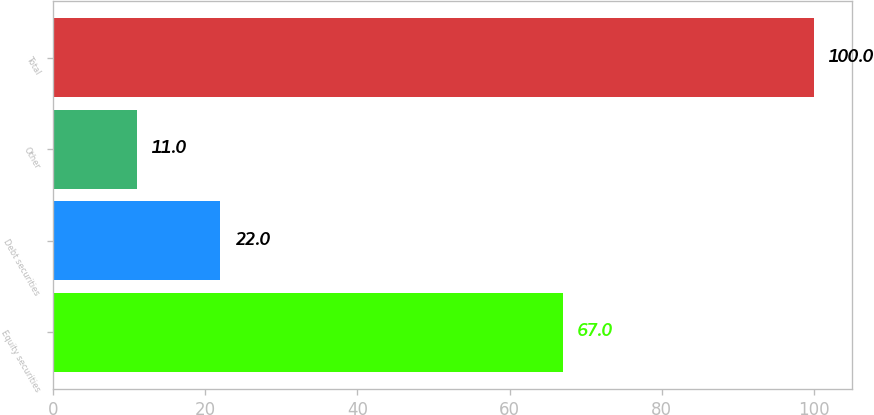Convert chart to OTSL. <chart><loc_0><loc_0><loc_500><loc_500><bar_chart><fcel>Equity securities<fcel>Debt securities<fcel>Other<fcel>Total<nl><fcel>67<fcel>22<fcel>11<fcel>100<nl></chart> 